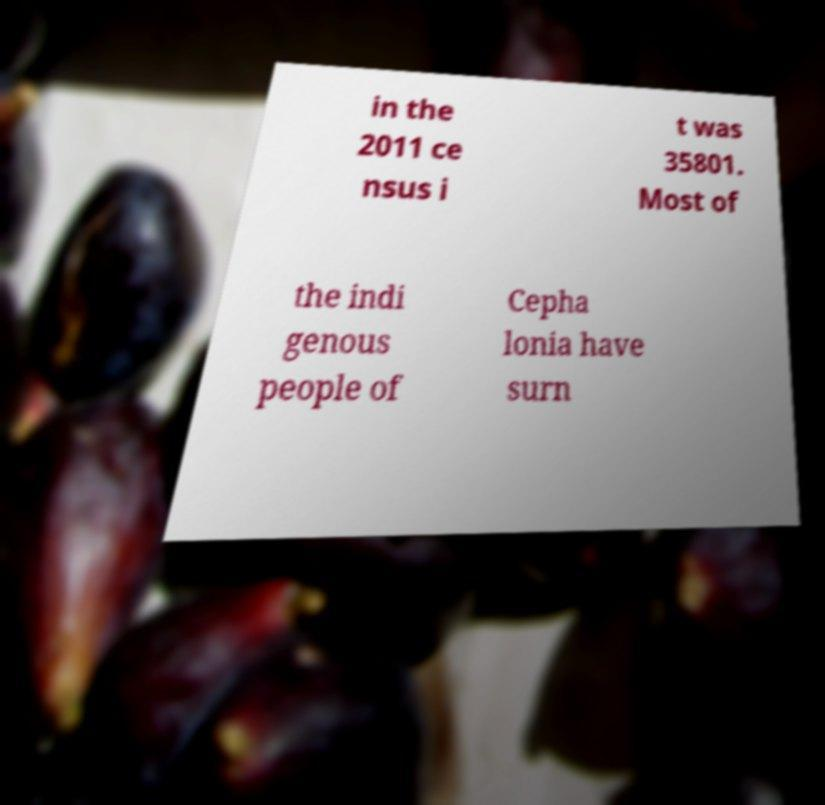For documentation purposes, I need the text within this image transcribed. Could you provide that? in the 2011 ce nsus i t was 35801. Most of the indi genous people of Cepha lonia have surn 